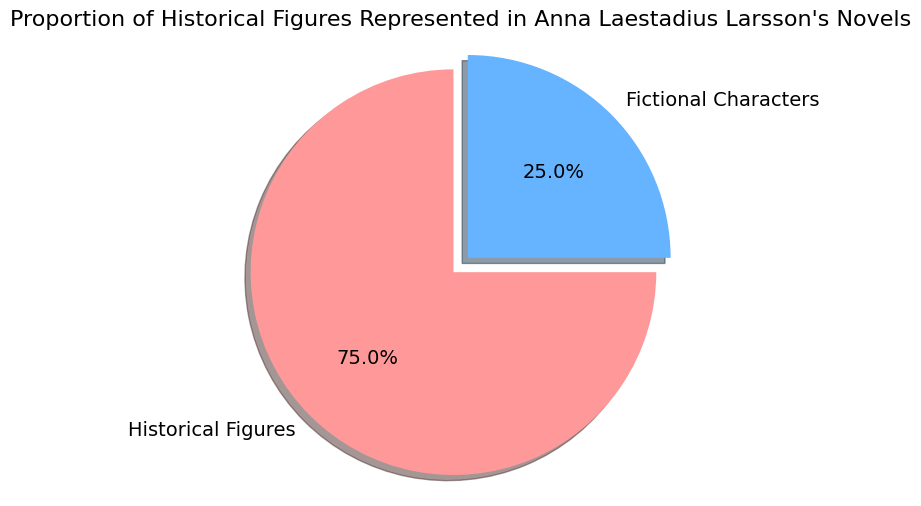What proportion of characters in Anna Laestadius Larsson's novels are historical figures? The pie chart shows that historical figures account for 75% of the characters in Anna Laestadius Larsson's novels. This is depicted by the larger segment of the pie chart labeled "Historical Figures" and annotated with "75.0%."
Answer: 75% What percentage of characters in the novels are fictional? According to the pie chart, fictional characters make up 25% of the total characters. This is indicated by the smaller pie segment labeled "Fictional Characters," which has an annotation of "25.0%."
Answer: 25% How much greater is the proportion of historical figures compared to fictional characters? The proportion of historical figures is 75%, and the proportion of fictional characters is 25%. The difference between these proportions is 75% - 25% = 50%.
Answer: 50% Which group has a larger representation in Anna Laestadius Larsson's novels, Historical Figures or Fictional Characters? The pie chart clearly shows that historical figures have a larger representation, making up 75% of the characters, compared to fictional characters which make up 25%.
Answer: Historical Figures If there are 200 characters in total in Larsson's novels, how many of them are historical figures? According to the pie chart, 75% of the characters are historical figures. To find the number of historical figures, multiply 75% by 200: (75/100) * 200 = 150.
Answer: 150 Which color represents the fictional characters in the pie chart? The pie chart uses a blue color to represent fictional characters. This can be seen where the "Fictional Characters" segment is labeled.
Answer: Blue If 40% of the fictional characters were converted to historical figures, what would be the new proportion of historical figures? Originally, 25% of characters are fictional, so converting 40% of these to historical figures means 40% of 25% = 10% characters are moved to historical figures. Adding this to the original proportion of historical figures (75%) gives a new proportion of 75% + 10% = 85%.
Answer: 85% What is the total percentage represented by both historical and fictional characters together? The pie chart shows that the total percentage of historical characters is 75% and fictional characters is 25%. Together, they add up to 75% + 25% = 100%.
Answer: 100% If one-third of the fictional characters were misclassified and are actually historical figures, what is the corrected proportion of each category? One-third of the fictional characters (25%) is 25% / 3 = approximately 8.33%. Moving these to historical figures reduces fictional characters to 25% - 8.33% ≈ 16.67% and increases historical figures to 75% + 8.33% ≈ 83.33%.
Answer: 83.33% historical figures, 16.67% fictional characters 